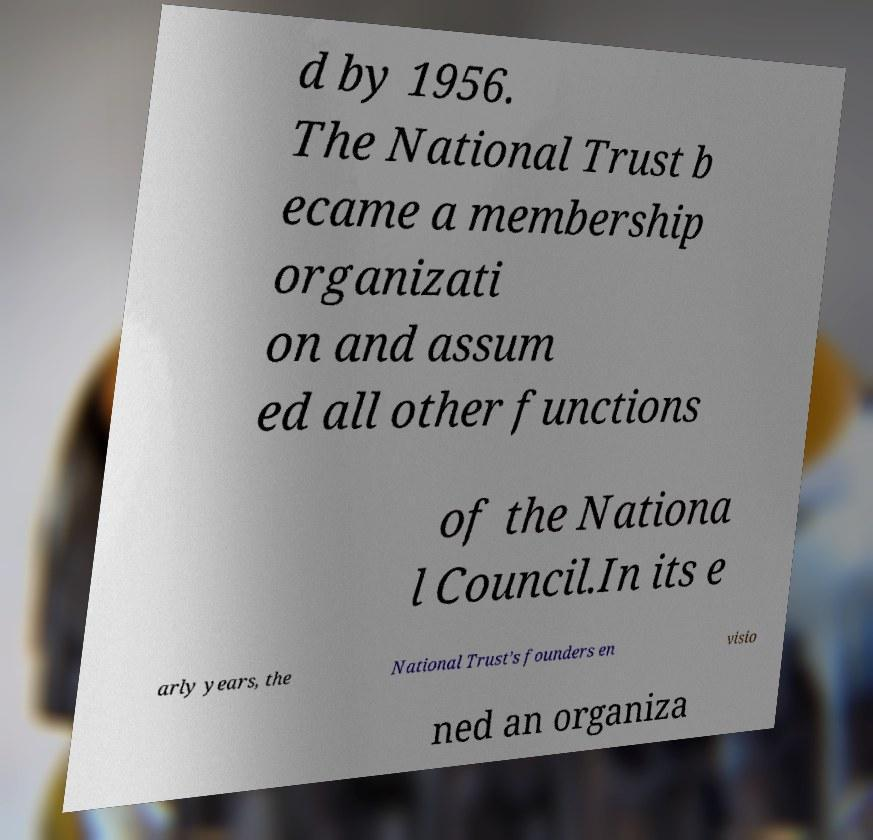I need the written content from this picture converted into text. Can you do that? d by 1956. The National Trust b ecame a membership organizati on and assum ed all other functions of the Nationa l Council.In its e arly years, the National Trust’s founders en visio ned an organiza 